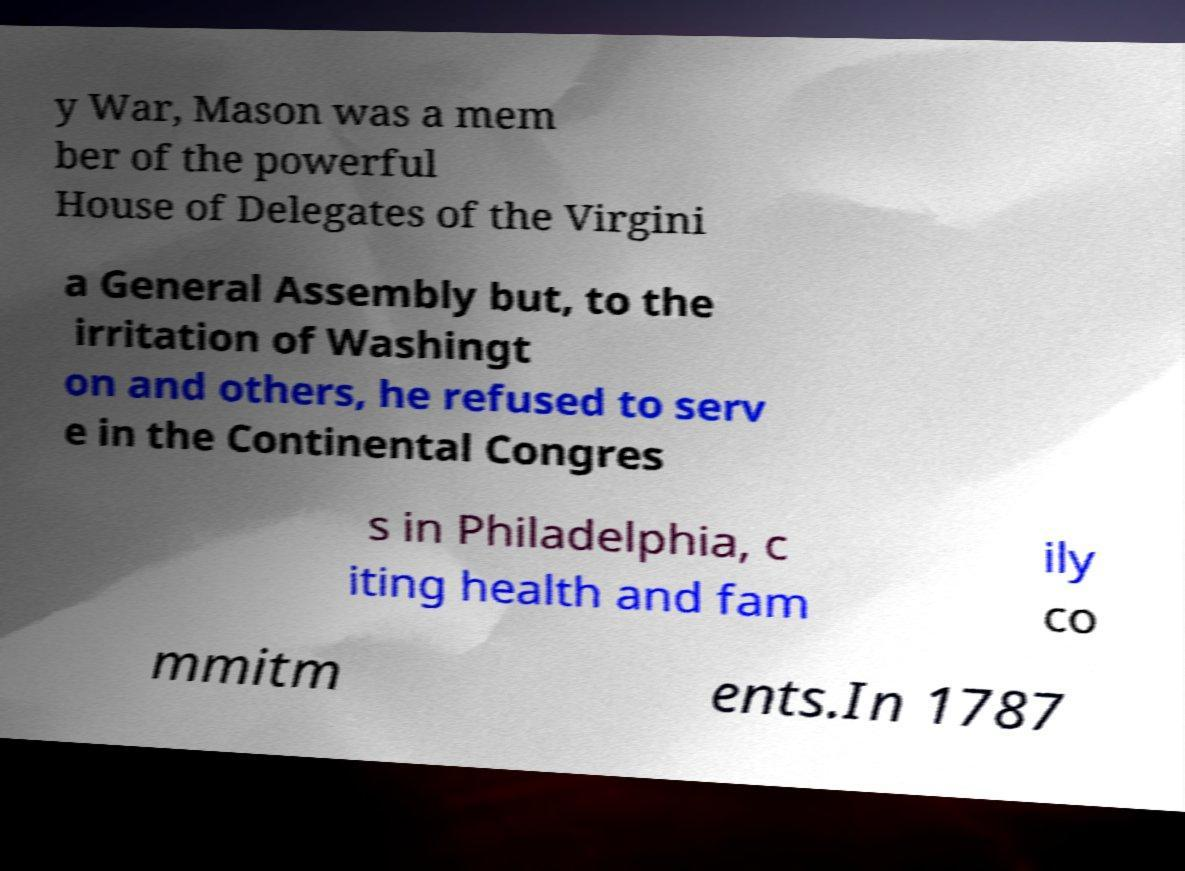What messages or text are displayed in this image? I need them in a readable, typed format. y War, Mason was a mem ber of the powerful House of Delegates of the Virgini a General Assembly but, to the irritation of Washingt on and others, he refused to serv e in the Continental Congres s in Philadelphia, c iting health and fam ily co mmitm ents.In 1787 